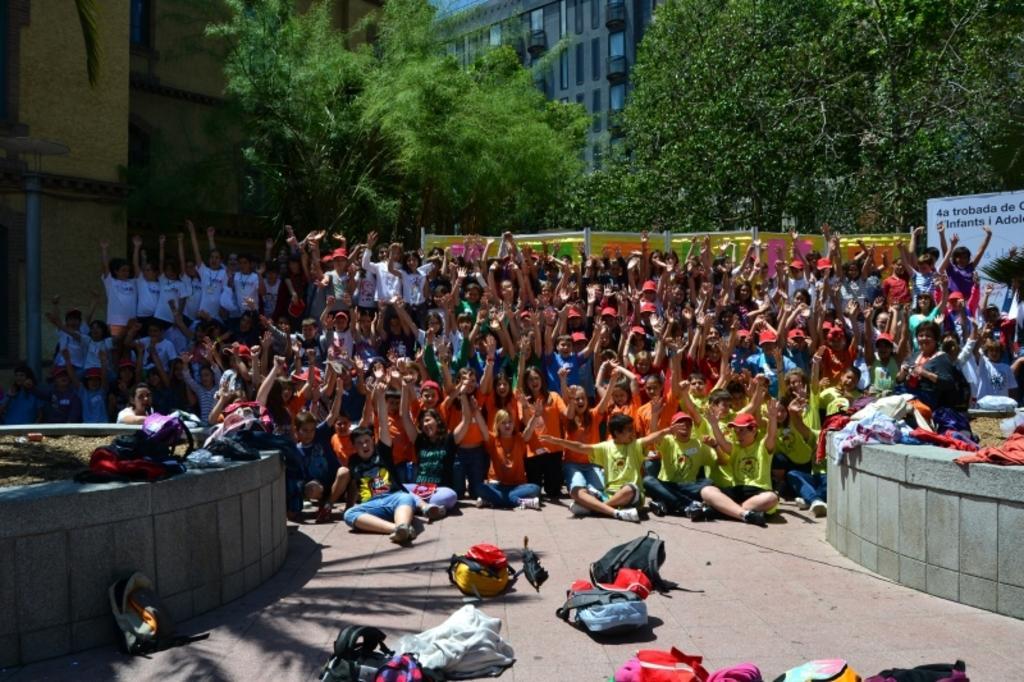Can you describe this image briefly? In this image there are few kids sitting on the floor having few bags. Behind there are few kids standing on the floor and raising their hands. On wall there are few bags and clothes. Behind the kids there are few banners and trees. Behind it there is a building. Kids are wearing different colors of shirts. 